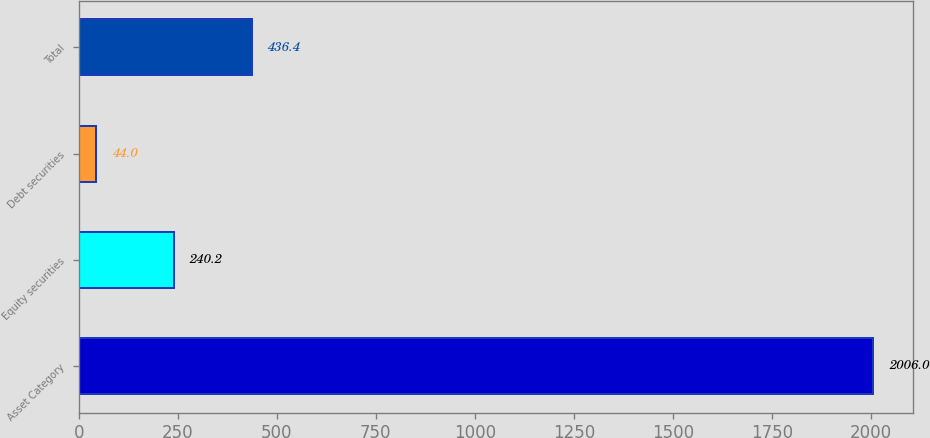<chart> <loc_0><loc_0><loc_500><loc_500><bar_chart><fcel>Asset Category<fcel>Equity securities<fcel>Debt securities<fcel>Total<nl><fcel>2006<fcel>240.2<fcel>44<fcel>436.4<nl></chart> 